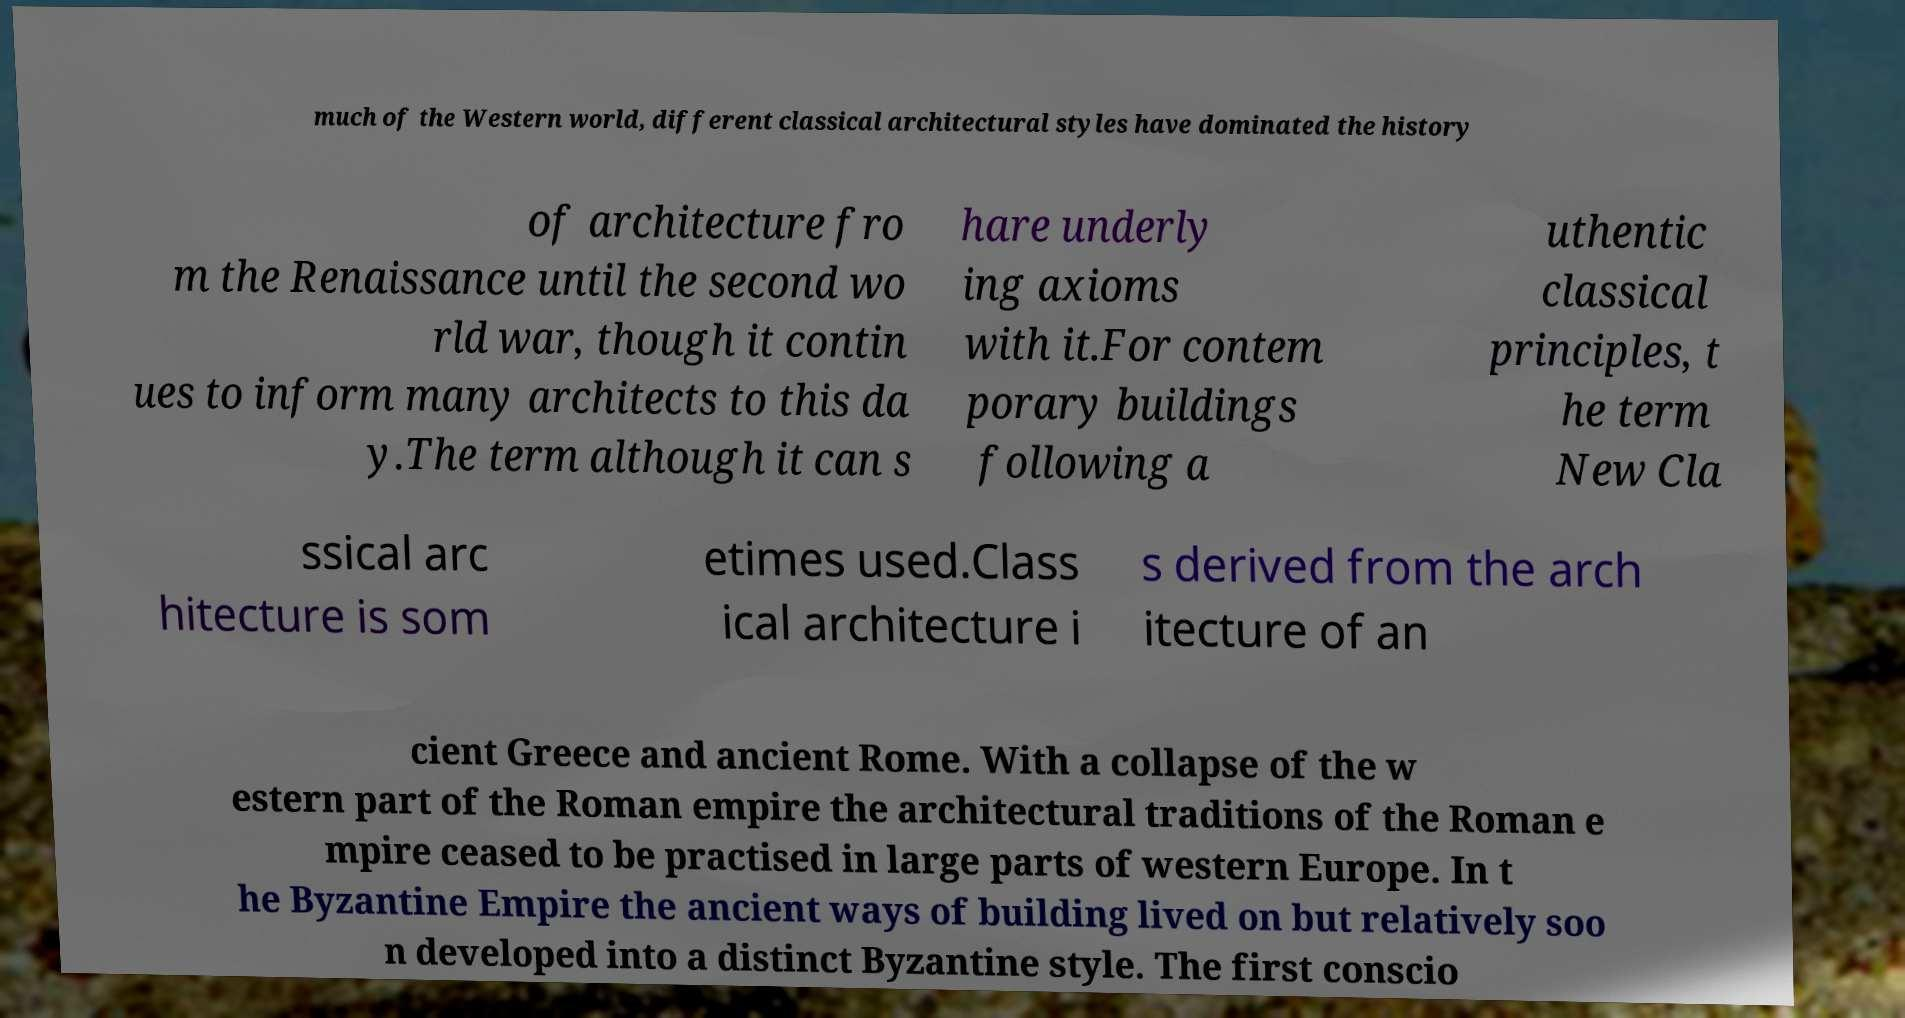Could you extract and type out the text from this image? much of the Western world, different classical architectural styles have dominated the history of architecture fro m the Renaissance until the second wo rld war, though it contin ues to inform many architects to this da y.The term although it can s hare underly ing axioms with it.For contem porary buildings following a uthentic classical principles, t he term New Cla ssical arc hitecture is som etimes used.Class ical architecture i s derived from the arch itecture of an cient Greece and ancient Rome. With a collapse of the w estern part of the Roman empire the architectural traditions of the Roman e mpire ceased to be practised in large parts of western Europe. In t he Byzantine Empire the ancient ways of building lived on but relatively soo n developed into a distinct Byzantine style. The first conscio 